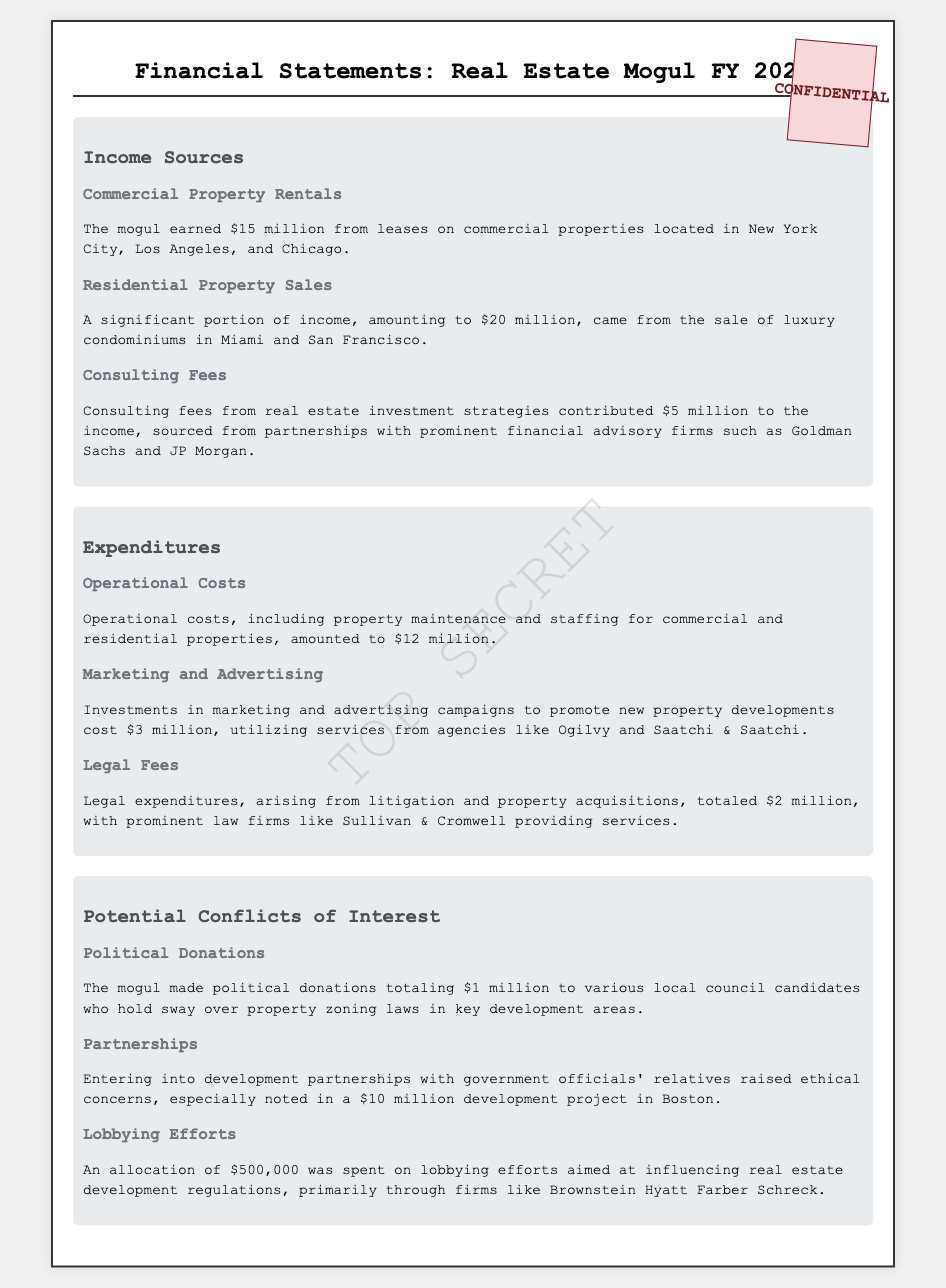what was the income from commercial property rentals? The document states that the mogul earned $15 million from leases on commercial properties.
Answer: $15 million what is the total income from residential property sales? The document specifies that a significant income of $20 million came from the sale of luxury condominiums.
Answer: $20 million how much was spent on legal fees? The document mentions that legal expenditures totaled $2 million, with services from prominent law firms.
Answer: $2 million who provided consulting fees? According to the document, consulting fees were sourced from partnerships with prominent financial advisory firms such as Goldman Sachs and JP Morgan.
Answer: Goldman Sachs and JP Morgan how much did the mogul spend lobbying? The document indicates an allocation of $500,000 for lobbying efforts aimed at influencing real estate regulations.
Answer: $500,000 what were the operational costs? The document states that operational costs amounted to $12 million for property maintenance and staffing.
Answer: $12 million which cities were mentioned for commercial property rentals? The document refers to commercial properties located in New York City, Los Angeles, and Chicago.
Answer: New York City, Los Angeles, and Chicago how much did the mogul donate to political candidates? The document mentions political donations totaling $1 million to local council candidates.
Answer: $1 million what development project raised ethical concerns? The document notes ethical concerns regarding a $10 million development project in Boston due to partnerships with government officials' relatives.
Answer: $10 million development project in Boston 